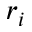Convert formula to latex. <formula><loc_0><loc_0><loc_500><loc_500>r _ { i }</formula> 